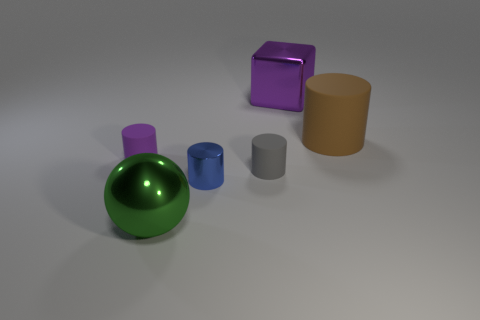There is a cube that is the same size as the brown object; what material is it? The cube appears to have a smooth and reflective surface, suggesting that it is likely made of a material such as plastic or polished metal, rather than a matte or rough material. 